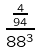Convert formula to latex. <formula><loc_0><loc_0><loc_500><loc_500>\frac { \frac { 4 } { 9 4 } } { 8 8 ^ { 3 } }</formula> 